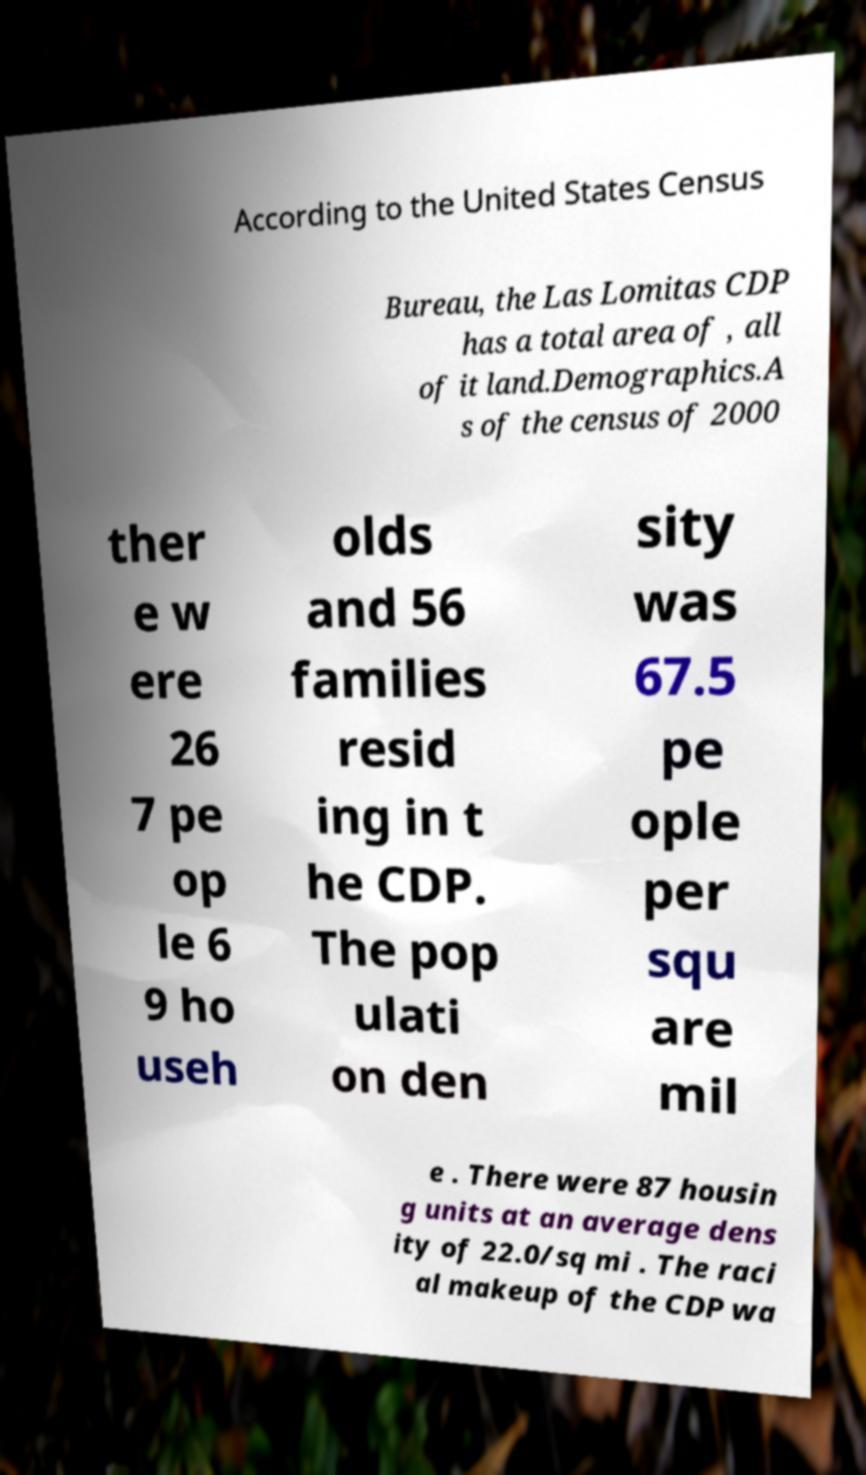Could you assist in decoding the text presented in this image and type it out clearly? According to the United States Census Bureau, the Las Lomitas CDP has a total area of , all of it land.Demographics.A s of the census of 2000 ther e w ere 26 7 pe op le 6 9 ho useh olds and 56 families resid ing in t he CDP. The pop ulati on den sity was 67.5 pe ople per squ are mil e . There were 87 housin g units at an average dens ity of 22.0/sq mi . The raci al makeup of the CDP wa 